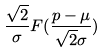Convert formula to latex. <formula><loc_0><loc_0><loc_500><loc_500>\frac { \sqrt { 2 } } { \sigma } F ( \frac { p - \mu } { \sqrt { 2 } \sigma } )</formula> 